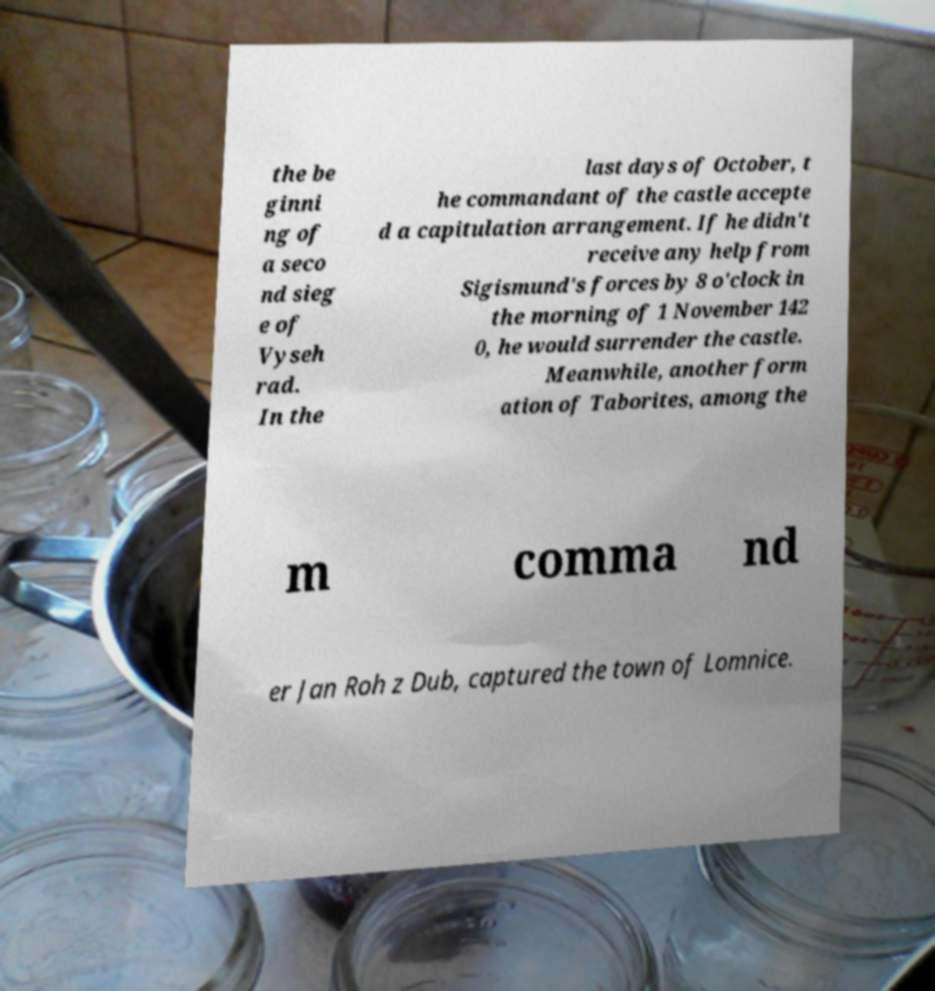For documentation purposes, I need the text within this image transcribed. Could you provide that? the be ginni ng of a seco nd sieg e of Vyseh rad. In the last days of October, t he commandant of the castle accepte d a capitulation arrangement. If he didn't receive any help from Sigismund's forces by 8 o'clock in the morning of 1 November 142 0, he would surrender the castle. Meanwhile, another form ation of Taborites, among the m comma nd er Jan Roh z Dub, captured the town of Lomnice. 